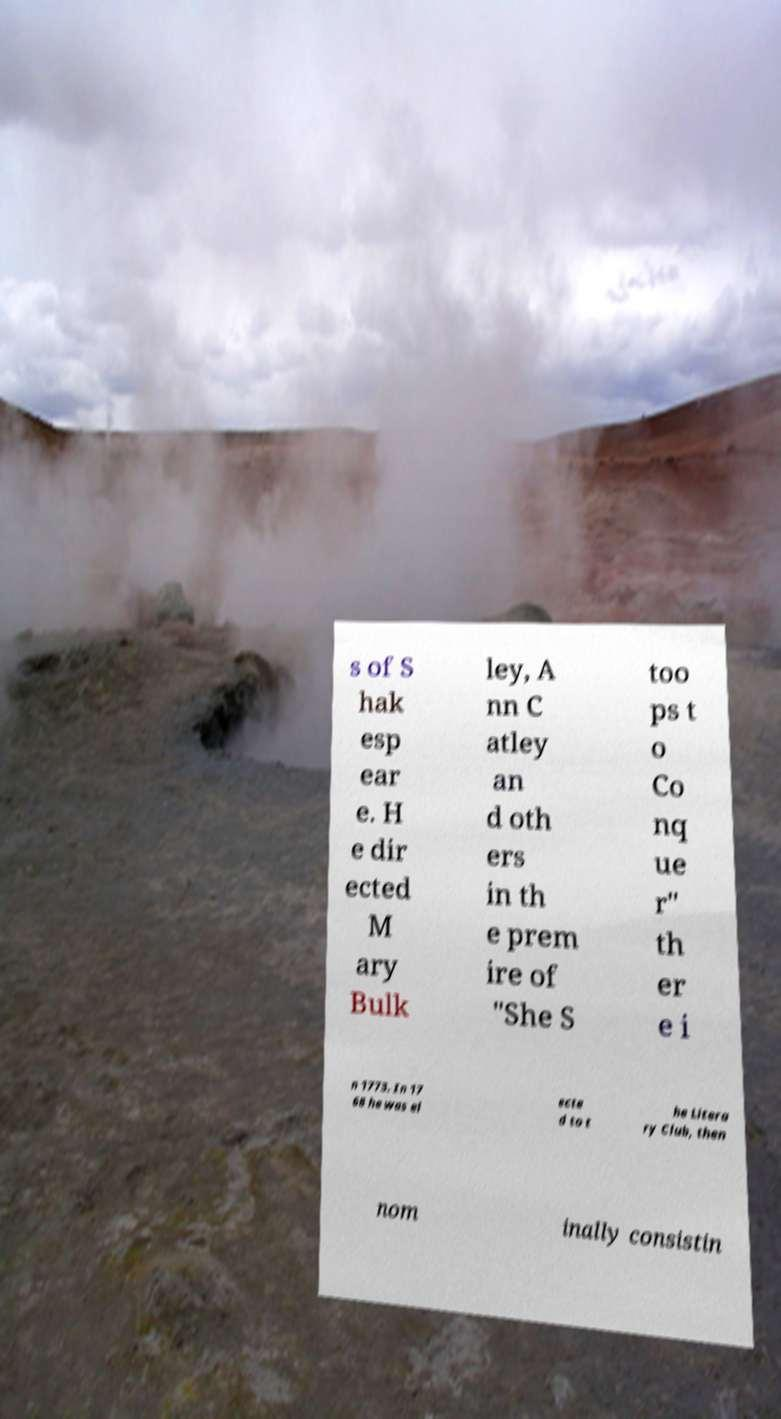I need the written content from this picture converted into text. Can you do that? s of S hak esp ear e. H e dir ected M ary Bulk ley, A nn C atley an d oth ers in th e prem ire of "She S too ps t o Co nq ue r" th er e i n 1773. In 17 68 he was el ecte d to t he Litera ry Club, then nom inally consistin 